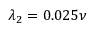<formula> <loc_0><loc_0><loc_500><loc_500>\lambda _ { 2 } = 0 . 0 2 5 \nu</formula> 